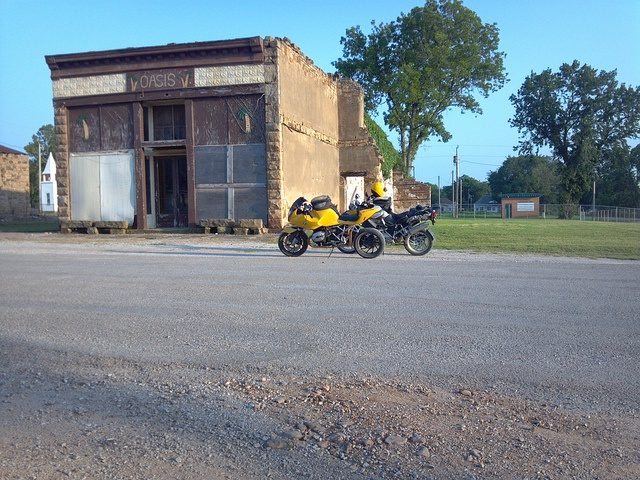Describe the objects in this image and their specific colors. I can see motorcycle in lightblue, black, gray, navy, and darkgray tones and motorcycle in lightblue, gray, black, navy, and darkgray tones in this image. 